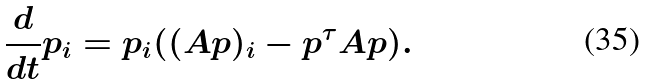Convert formula to latex. <formula><loc_0><loc_0><loc_500><loc_500>\frac { d } { d t } p _ { i } = p _ { i } ( ( A p ) _ { i } - p ^ { \tau } A p ) .</formula> 